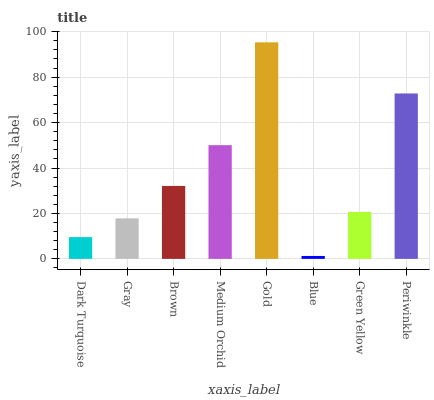Is Blue the minimum?
Answer yes or no. Yes. Is Gold the maximum?
Answer yes or no. Yes. Is Gray the minimum?
Answer yes or no. No. Is Gray the maximum?
Answer yes or no. No. Is Gray greater than Dark Turquoise?
Answer yes or no. Yes. Is Dark Turquoise less than Gray?
Answer yes or no. Yes. Is Dark Turquoise greater than Gray?
Answer yes or no. No. Is Gray less than Dark Turquoise?
Answer yes or no. No. Is Brown the high median?
Answer yes or no. Yes. Is Green Yellow the low median?
Answer yes or no. Yes. Is Dark Turquoise the high median?
Answer yes or no. No. Is Medium Orchid the low median?
Answer yes or no. No. 